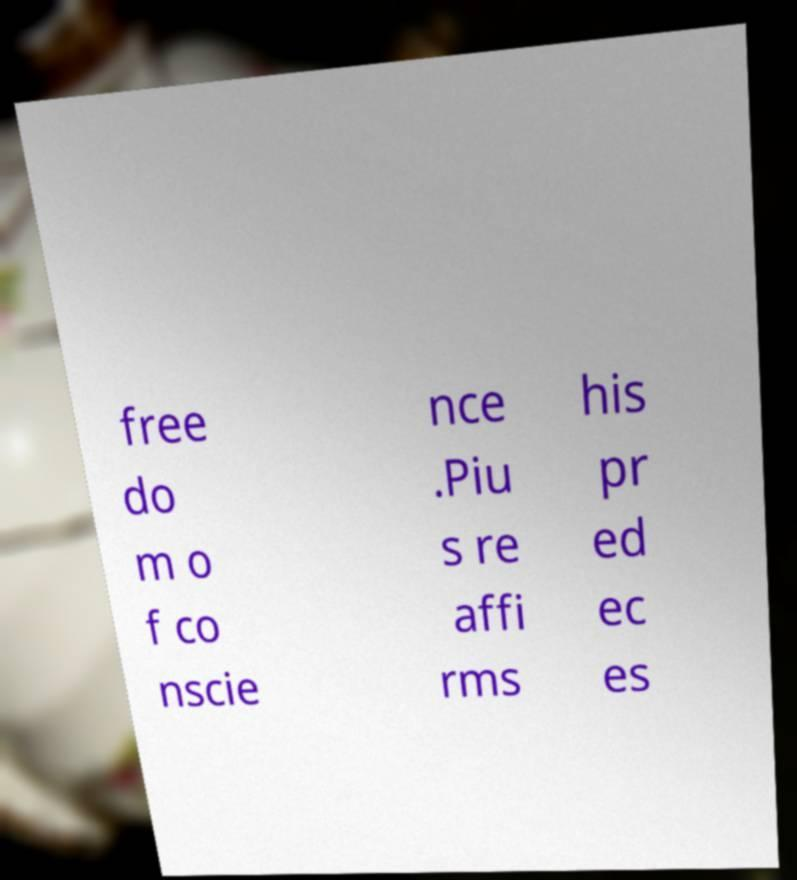I need the written content from this picture converted into text. Can you do that? free do m o f co nscie nce .Piu s re affi rms his pr ed ec es 